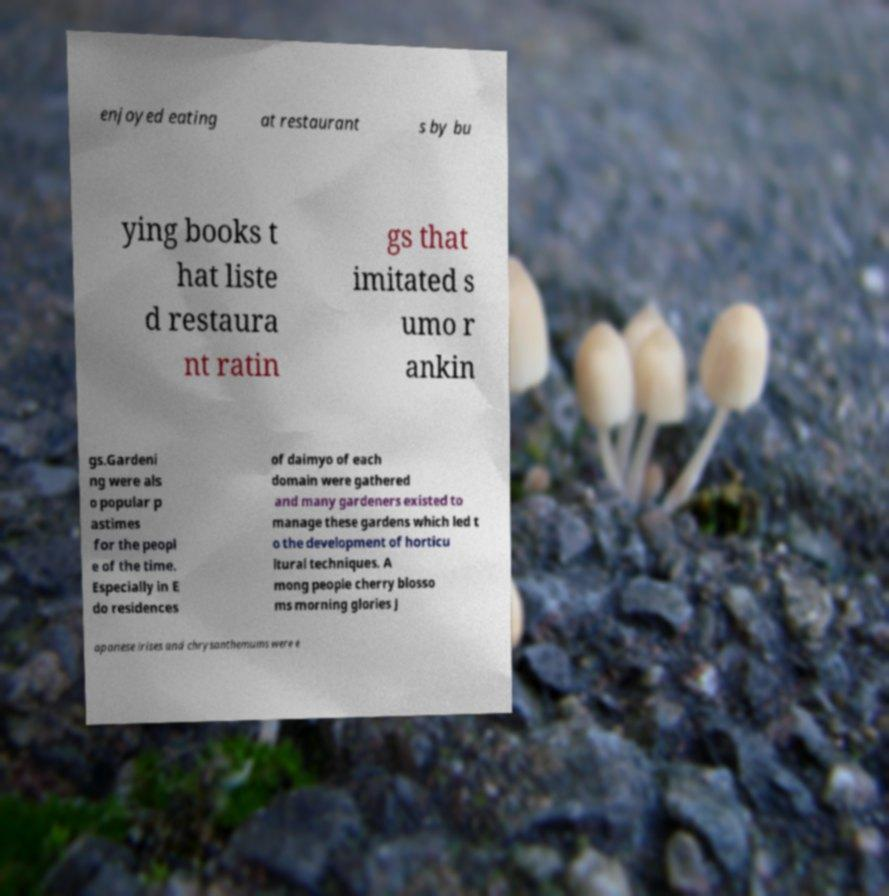Could you extract and type out the text from this image? enjoyed eating at restaurant s by bu ying books t hat liste d restaura nt ratin gs that imitated s umo r ankin gs.Gardeni ng were als o popular p astimes for the peopl e of the time. Especially in E do residences of daimyo of each domain were gathered and many gardeners existed to manage these gardens which led t o the development of horticu ltural techniques. A mong people cherry blosso ms morning glories J apanese irises and chrysanthemums were e 